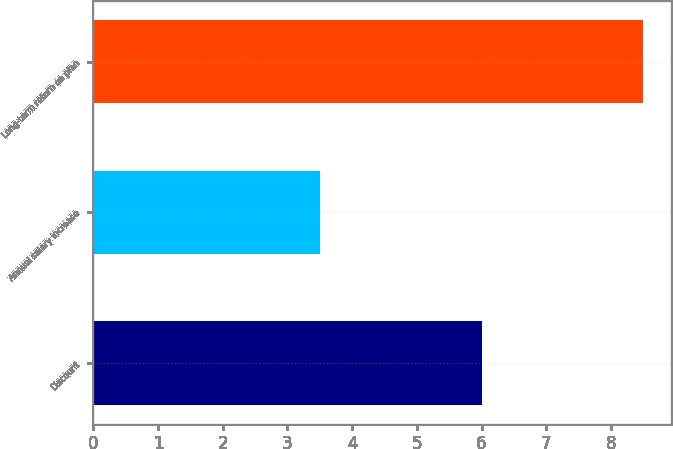Convert chart. <chart><loc_0><loc_0><loc_500><loc_500><bar_chart><fcel>Discount<fcel>Annual salary increase<fcel>Long-term return on plan<nl><fcel>6<fcel>3.5<fcel>8.5<nl></chart> 